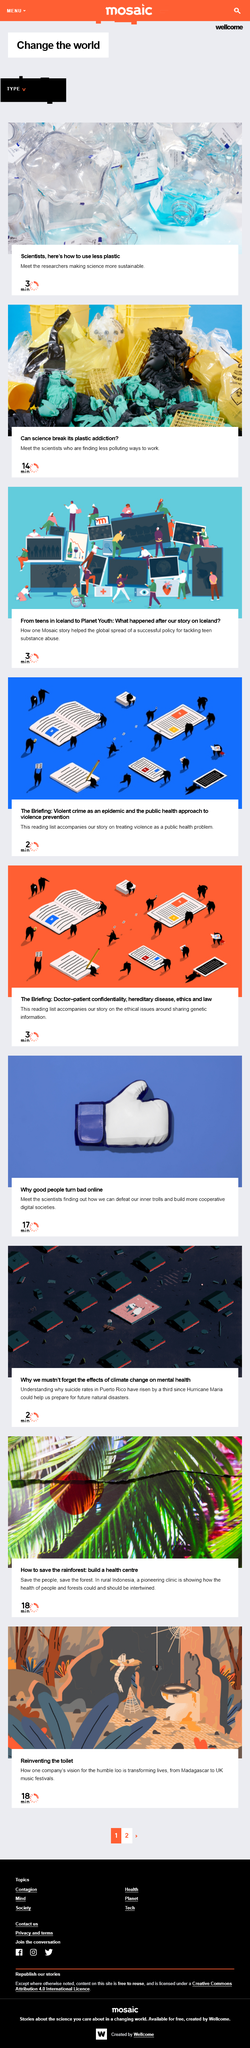Outline some significant characteristics in this image. The first video is three minutes in length. There are three videos presented. The second video is estimated to be approximately 14 minutes in length. 